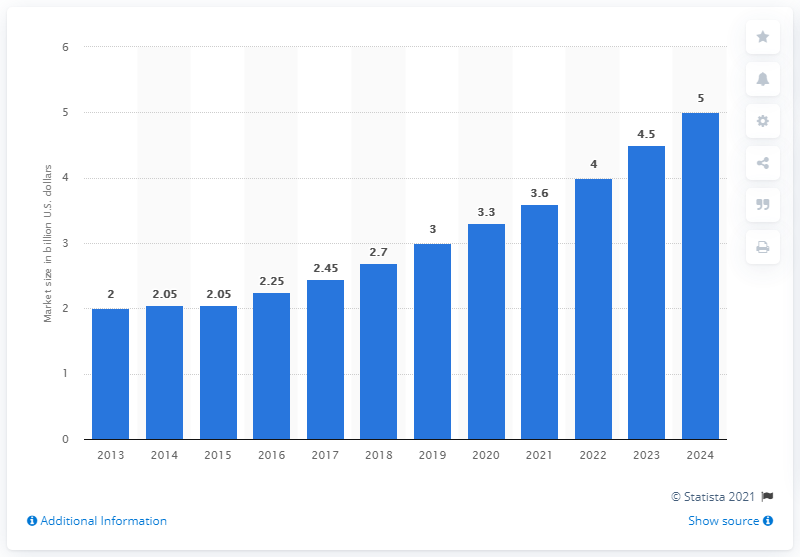Point out several critical features in this image. The estimated global market size for neurostimulation devices in 2021 is projected to be 3.6. 